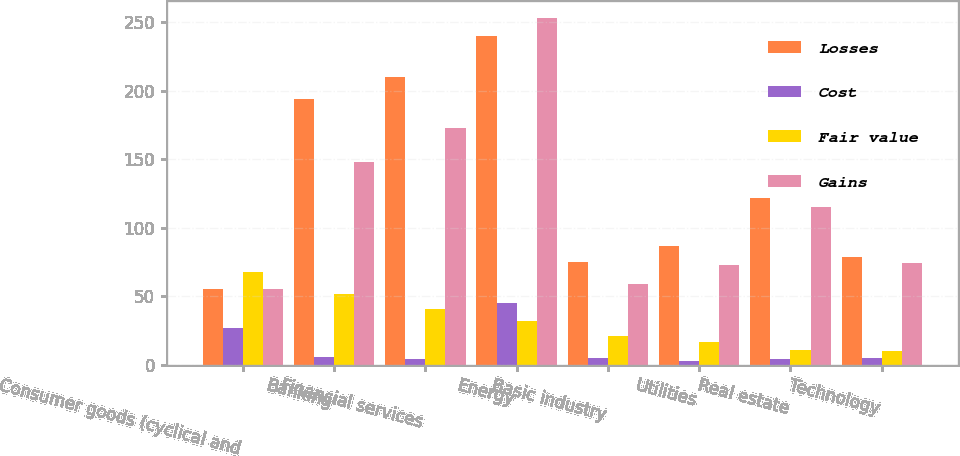<chart> <loc_0><loc_0><loc_500><loc_500><stacked_bar_chart><ecel><fcel>Consumer goods (cyclical and<fcel>Banking<fcel>Financial services<fcel>Energy<fcel>Basic industry<fcel>Utilities<fcel>Real estate<fcel>Technology<nl><fcel>Losses<fcel>55.5<fcel>194<fcel>210<fcel>240<fcel>75<fcel>87<fcel>122<fcel>79<nl><fcel>Cost<fcel>27<fcel>6<fcel>4<fcel>45<fcel>5<fcel>3<fcel>4<fcel>5<nl><fcel>Fair value<fcel>68<fcel>52<fcel>41<fcel>32<fcel>21<fcel>17<fcel>11<fcel>10<nl><fcel>Gains<fcel>55.5<fcel>148<fcel>173<fcel>253<fcel>59<fcel>73<fcel>115<fcel>74<nl></chart> 